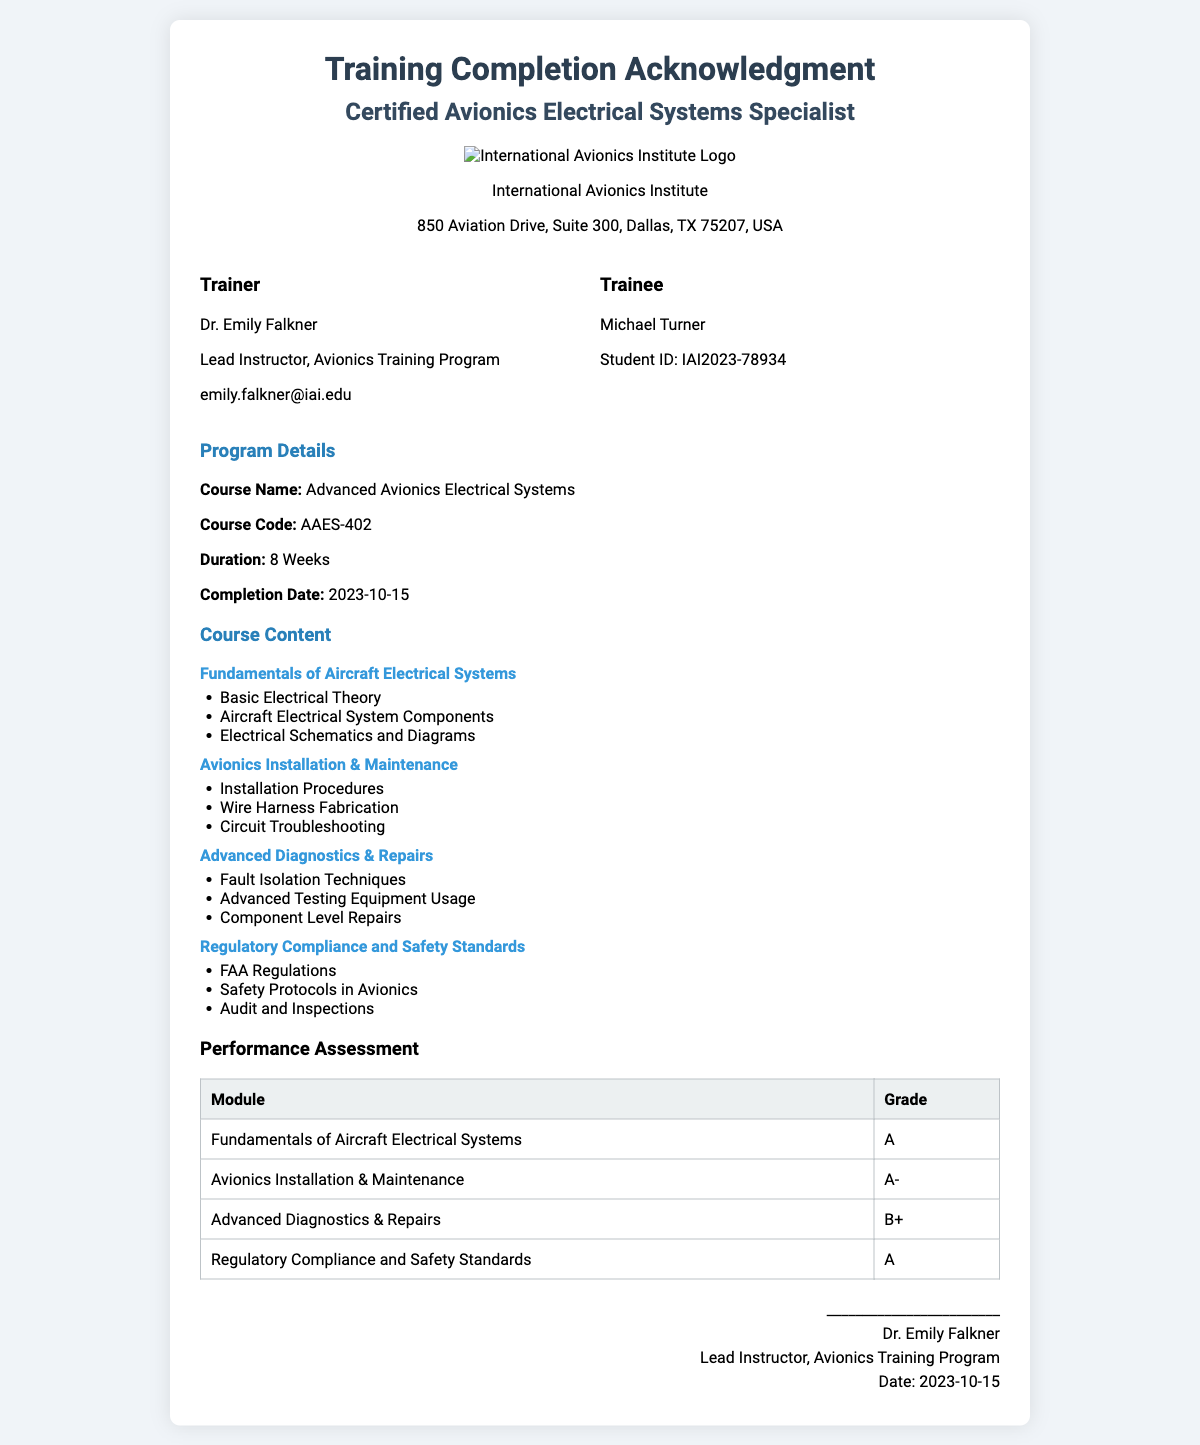What is the course name? The course name is explicitly stated in the program details section of the document.
Answer: Advanced Avionics Electrical Systems Who is the trainer? The trainer's name is listed in the details section, along with their title and contact information.
Answer: Dr. Emily Falkner What is the duration of the course? The duration is clearly mentioned in the program details section of the document.
Answer: 8 Weeks What was the completion date of the training? The completion date can be found in the program details section.
Answer: 2023-10-15 What grade did the trainee receive for the module "Avionics Installation & Maintenance"? The grade can be found in the performance assessment table associated with that module.
Answer: A- How many modules are covered in the course content? The number of modules is determined by counting the modules listed under the course content section.
Answer: 4 What is the name of the institution providing the training? The institution's name is highlighted at the center of the document before the details section.
Answer: International Avionics Institute What is included in the advanced diagnostics module? The items listed under this module in the course content section provide the answer.
Answer: Fault Isolation Techniques, Advanced Testing Equipment Usage, Component Level Repairs What is the email address of the trainer? The trainer's email is included in their details section.
Answer: emily.falkner@iai.edu 